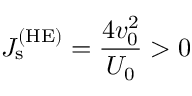Convert formula to latex. <formula><loc_0><loc_0><loc_500><loc_500>J _ { s } ^ { ( H E ) } = \frac { 4 v _ { 0 } ^ { 2 } } { U _ { 0 } } > 0</formula> 